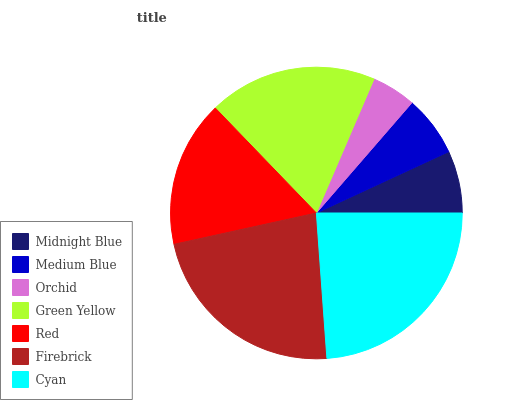Is Orchid the minimum?
Answer yes or no. Yes. Is Cyan the maximum?
Answer yes or no. Yes. Is Medium Blue the minimum?
Answer yes or no. No. Is Medium Blue the maximum?
Answer yes or no. No. Is Midnight Blue greater than Medium Blue?
Answer yes or no. Yes. Is Medium Blue less than Midnight Blue?
Answer yes or no. Yes. Is Medium Blue greater than Midnight Blue?
Answer yes or no. No. Is Midnight Blue less than Medium Blue?
Answer yes or no. No. Is Red the high median?
Answer yes or no. Yes. Is Red the low median?
Answer yes or no. Yes. Is Medium Blue the high median?
Answer yes or no. No. Is Green Yellow the low median?
Answer yes or no. No. 